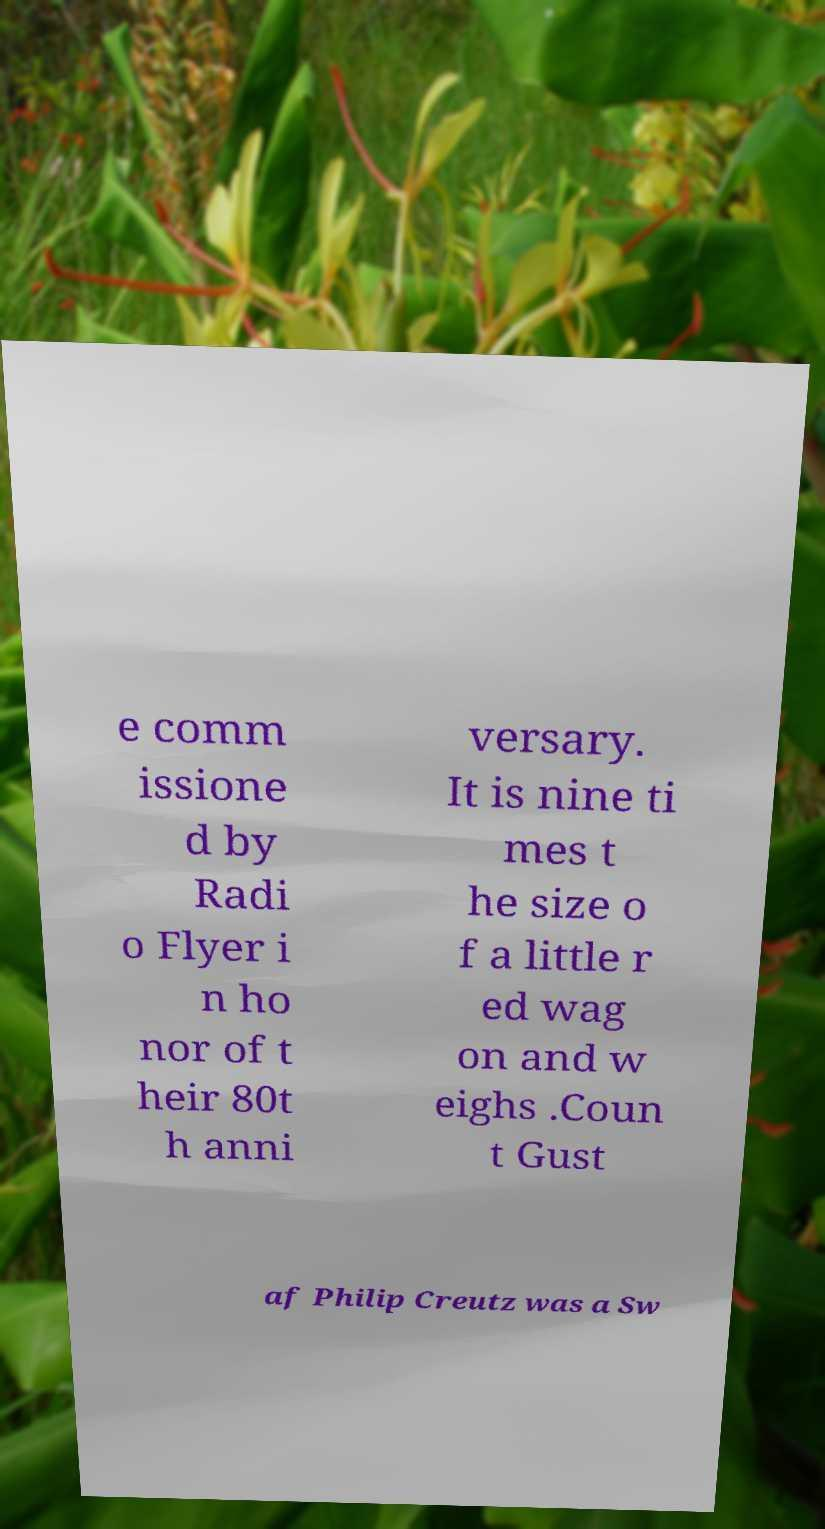There's text embedded in this image that I need extracted. Can you transcribe it verbatim? e comm issione d by Radi o Flyer i n ho nor of t heir 80t h anni versary. It is nine ti mes t he size o f a little r ed wag on and w eighs .Coun t Gust af Philip Creutz was a Sw 